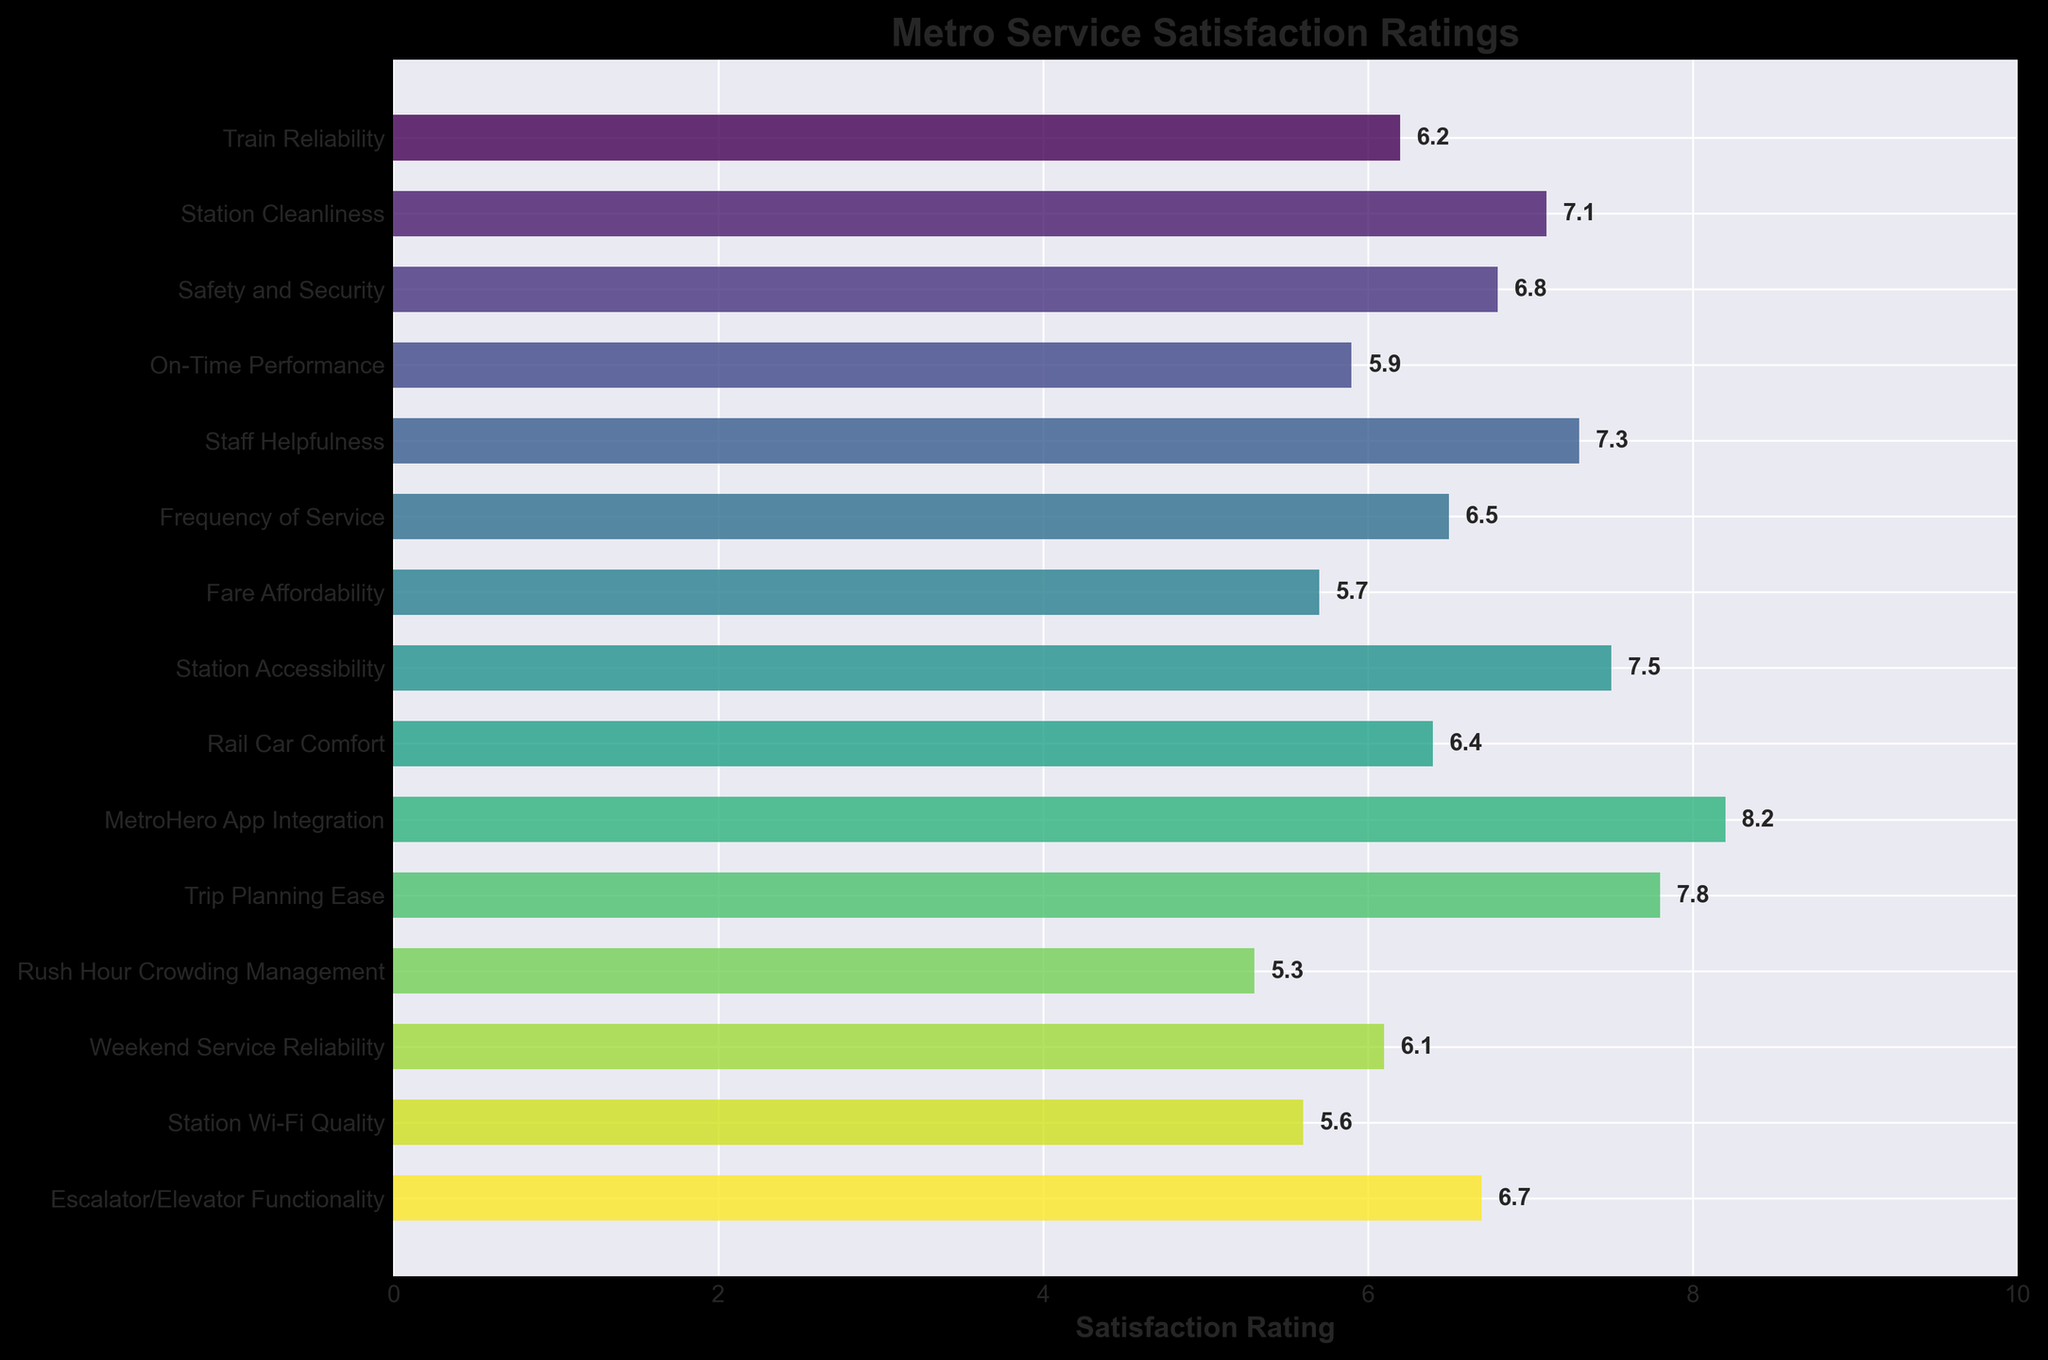Which aspect has the highest satisfaction rating? The bar with the longest length represents the highest satisfaction rating, which is for the MetroHero App Integration.
Answer: MetroHero App Integration Which aspect has the lowest satisfaction rating? The shortest bar indicates the aspect with the lowest satisfaction rating, which is Rush Hour Crowding Management.
Answer: Rush Hour Crowding Management How does the satisfaction rating for Train Reliability compare to On-Time Performance? The length of the bar for Train Reliability (6.2) is longer than the bar for On-Time Performance (5.9), indicating that Train Reliability has a higher satisfaction rating.
Answer: Train Reliability is higher What is the difference in satisfaction ratings between Station Accessibility and Fare Affordability? Station Accessibility has a rating of 7.5, and Fare Affordability has a rating of 5.7. Subtracting 5.7 from 7.5 gives the difference.
Answer: 1.8 How many aspects have a satisfaction rating higher than 7.0? Count the bars that have lengths extending beyond the 7.0 mark.
Answer: 4 What is the average satisfaction rating of Safety and Security, Rail Car Comfort, and Station Wi-Fi Quality? Sum the ratings (6.8 + 6.4 + 5.6) and divide by the number of aspects (3). The sum is 18.8, and the average is 18.8 / 3.
Answer: 6.27 Which aspect has a satisfaction rating closest to 6.0? Identify the bar closest to the 6.0 mark. Weekend Service Reliability has a rating of 6.1, which is closest to 6.0.
Answer: Weekend Service Reliability Are there more aspects with a satisfaction rating above or below 6.5? Count the bars with ratings above 6.5 and those below 6.5, then compare the counts.
Answer: Below 6.5 Is the satisfaction rating for Escalator/Elevator Functionality higher or lower than the median satisfaction rating of all aspects? First, list all ratings, find the median (6.5), and compare it to the Escalator/Elevator Functionality rating (6.7).
Answer: Higher What’s the sum of satisfaction ratings for Station Cleanliness, Staff Helpfulness, and Trip Planning Ease? Add the satisfaction ratings for these aspects (7.1 + 7.3 + 7.8). The sum is 22.2.
Answer: 22.2 